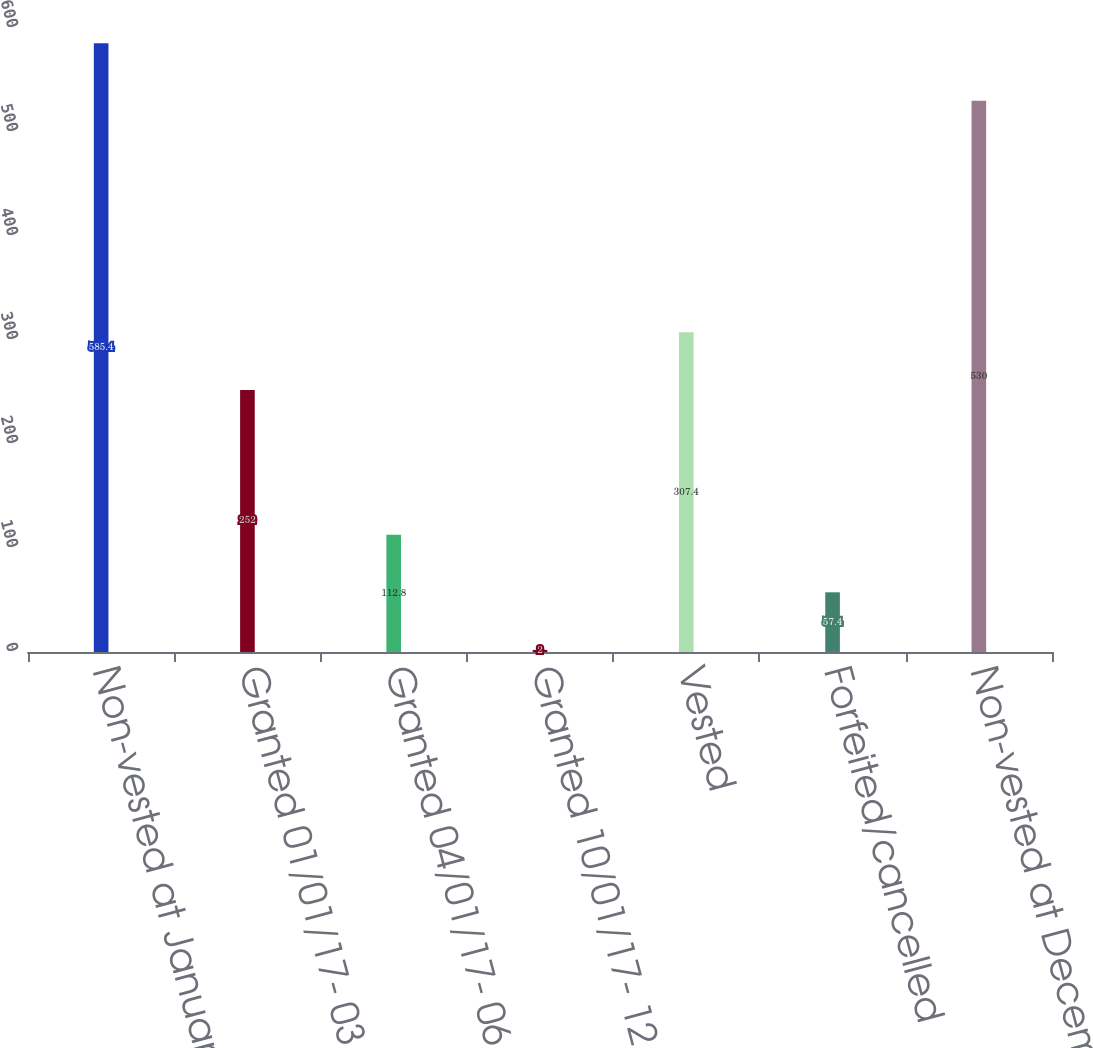<chart> <loc_0><loc_0><loc_500><loc_500><bar_chart><fcel>Non-vested at January 1 2017<fcel>Granted 01/01/17- 03/31/17<fcel>Granted 04/01/17- 06/30/17<fcel>Granted 10/01/17- 12/31/17<fcel>Vested<fcel>Forfeited/cancelled<fcel>Non-vested at December 31 2017<nl><fcel>585.4<fcel>252<fcel>112.8<fcel>2<fcel>307.4<fcel>57.4<fcel>530<nl></chart> 